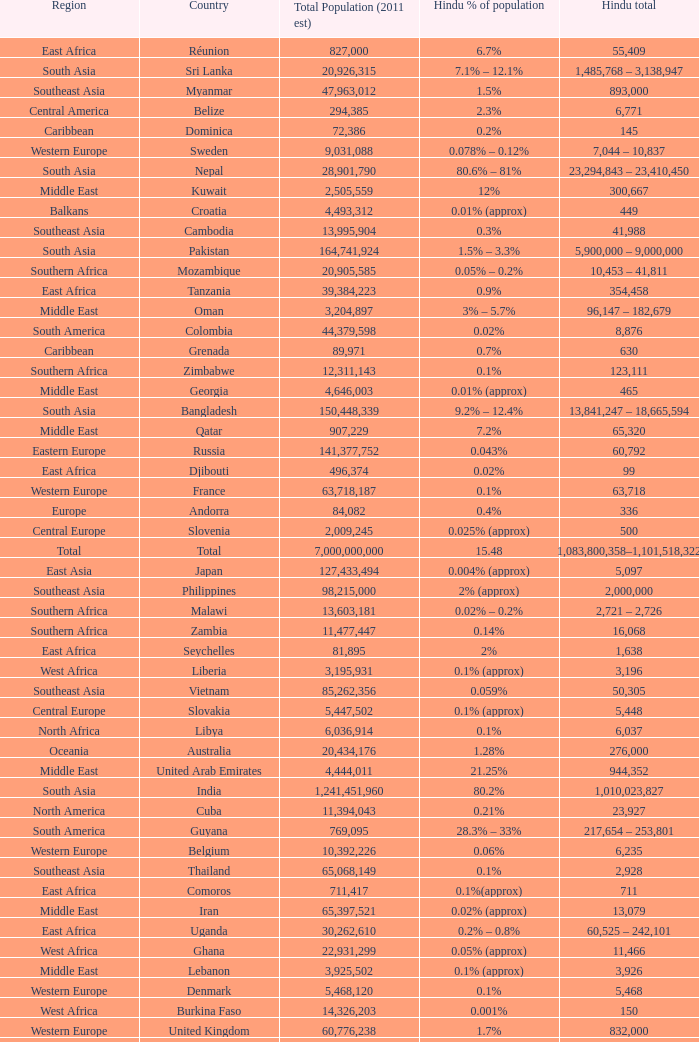Total Population (2011 est) larger than 30,262,610, and a Hindu total of 63,718 involves what country? France. 